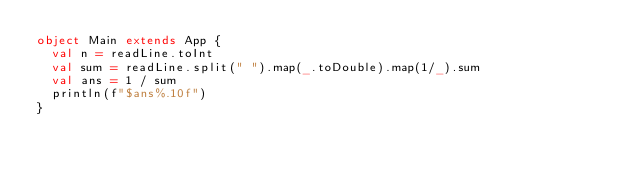<code> <loc_0><loc_0><loc_500><loc_500><_Scala_>object Main extends App {
  val n = readLine.toInt
  val sum = readLine.split(" ").map(_.toDouble).map(1/_).sum
  val ans = 1 / sum
  println(f"$ans%.10f")
}</code> 